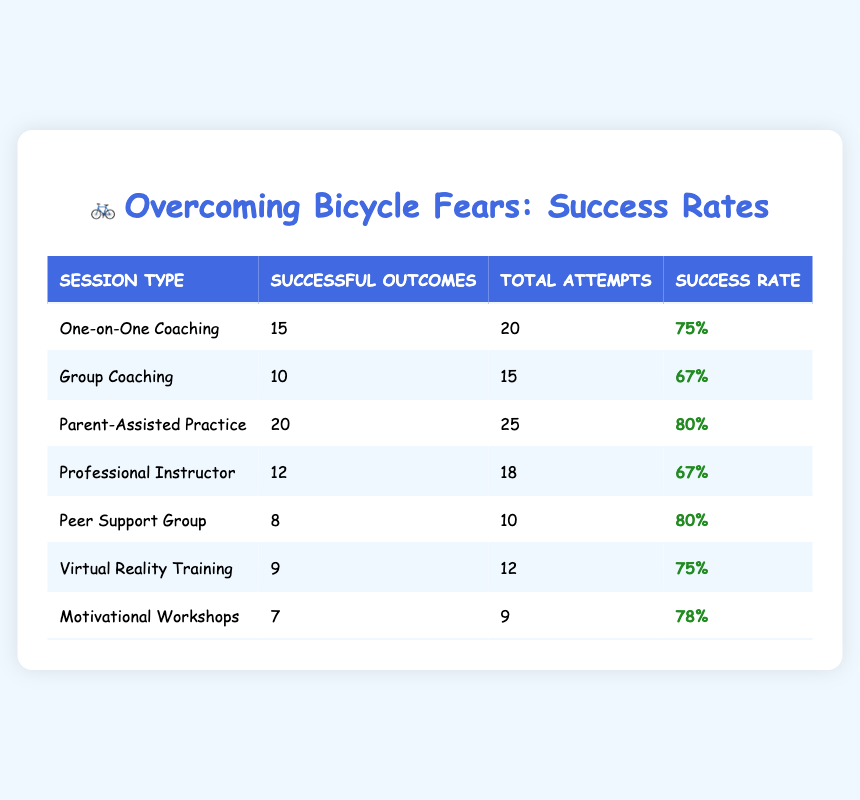What is the success rate for Parent-Assisted Practice? The success rate for Parent-Assisted Practice is given in the table as 80%.
Answer: 80% Which session type had the least successful outcomes? By comparing the successful outcomes across all session types, Peer Support Group has the least successful outcomes with 8.
Answer: 8 What is the total number of attempts for the One-on-One Coaching session type? The table shows that the total attempts for One-on-One Coaching is 20.
Answer: 20 Which two session types had the highest success rates? We look at the success rates: Parent-Assisted Practice at 80% and both Peer Support Group and Motivational Workshops at 80%. So, the highest are Parent-Assisted Practice and Peer Support Group.
Answer: Parent-Assisted Practice and Peer Support Group If I wanted to find the average success rate of all session types, what would that be? We first sum the success rates: 75% + 67% + 80% + 67% + 80% + 75% + 78% = 522%. We then divide by the number of session types, which is 7: 522% / 7 = 74.57%. Thus, the average success rate is approximately 74.57%.
Answer: 74.57% Is the success rate for Motivational Workshops greater than that of Group Coaching? The success rate for Motivational Workshops is 78% and for Group Coaching, it is 67%. Since 78% is indeed greater than 67%, the answer is yes.
Answer: Yes How many total successful outcomes were recorded for Virtual Reality Training? The table indicates that the successful outcomes for Virtual Reality Training are 9.
Answer: 9 What is the difference in successful outcomes between One-on-One Coaching and Professional Instructor sessions? One-on-One Coaching has 15 successful outcomes, while Professional Instructor has 12. The difference is 15 - 12 = 3.
Answer: 3 Was Peer Support Group more successful than Group Coaching in overcoming bicycle fears? Peer Support Group had 8 successful outcomes while Group Coaching had 10. Therefore, Peer Support Group was less successful.
Answer: No 